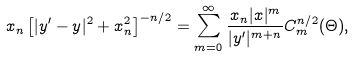Convert formula to latex. <formula><loc_0><loc_0><loc_500><loc_500>x _ { n } \left [ | y ^ { \prime } - y | ^ { 2 } + x _ { n } ^ { 2 } \right ] ^ { - n / 2 } = \sum _ { m = 0 } ^ { \infty } \frac { x _ { n } | x | ^ { m } } { | y ^ { \prime } | ^ { m + n } } C _ { m } ^ { n / 2 } ( \Theta ) ,</formula> 